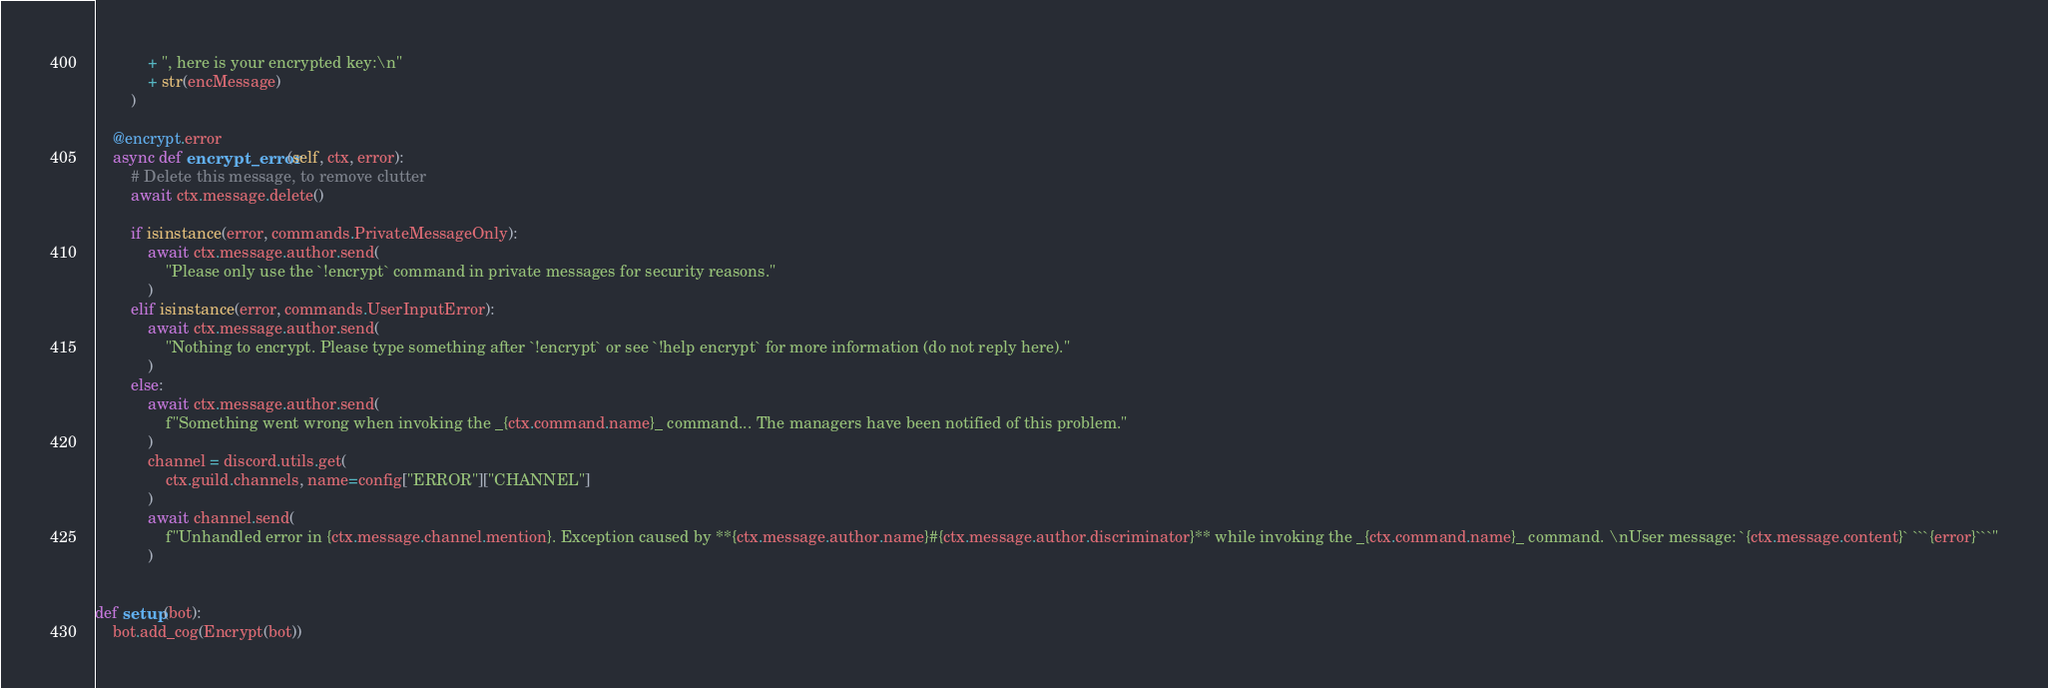Convert code to text. <code><loc_0><loc_0><loc_500><loc_500><_Python_>            + ", here is your encrypted key:\n"
            + str(encMessage)
        )

    @encrypt.error
    async def encrypt_error(self, ctx, error):
        # Delete this message, to remove clutter
        await ctx.message.delete()

        if isinstance(error, commands.PrivateMessageOnly):
            await ctx.message.author.send(
                "Please only use the `!encrypt` command in private messages for security reasons."
            )
        elif isinstance(error, commands.UserInputError):
            await ctx.message.author.send(
                "Nothing to encrypt. Please type something after `!encrypt` or see `!help encrypt` for more information (do not reply here)."
            )
        else:
            await ctx.message.author.send(
                f"Something went wrong when invoking the _{ctx.command.name}_ command... The managers have been notified of this problem."
            )
            channel = discord.utils.get(
                ctx.guild.channels, name=config["ERROR"]["CHANNEL"]
            )
            await channel.send(
                f"Unhandled error in {ctx.message.channel.mention}. Exception caused by **{ctx.message.author.name}#{ctx.message.author.discriminator}** while invoking the _{ctx.command.name}_ command. \nUser message: `{ctx.message.content}` ```{error}```"
            )


def setup(bot):
    bot.add_cog(Encrypt(bot))
</code> 